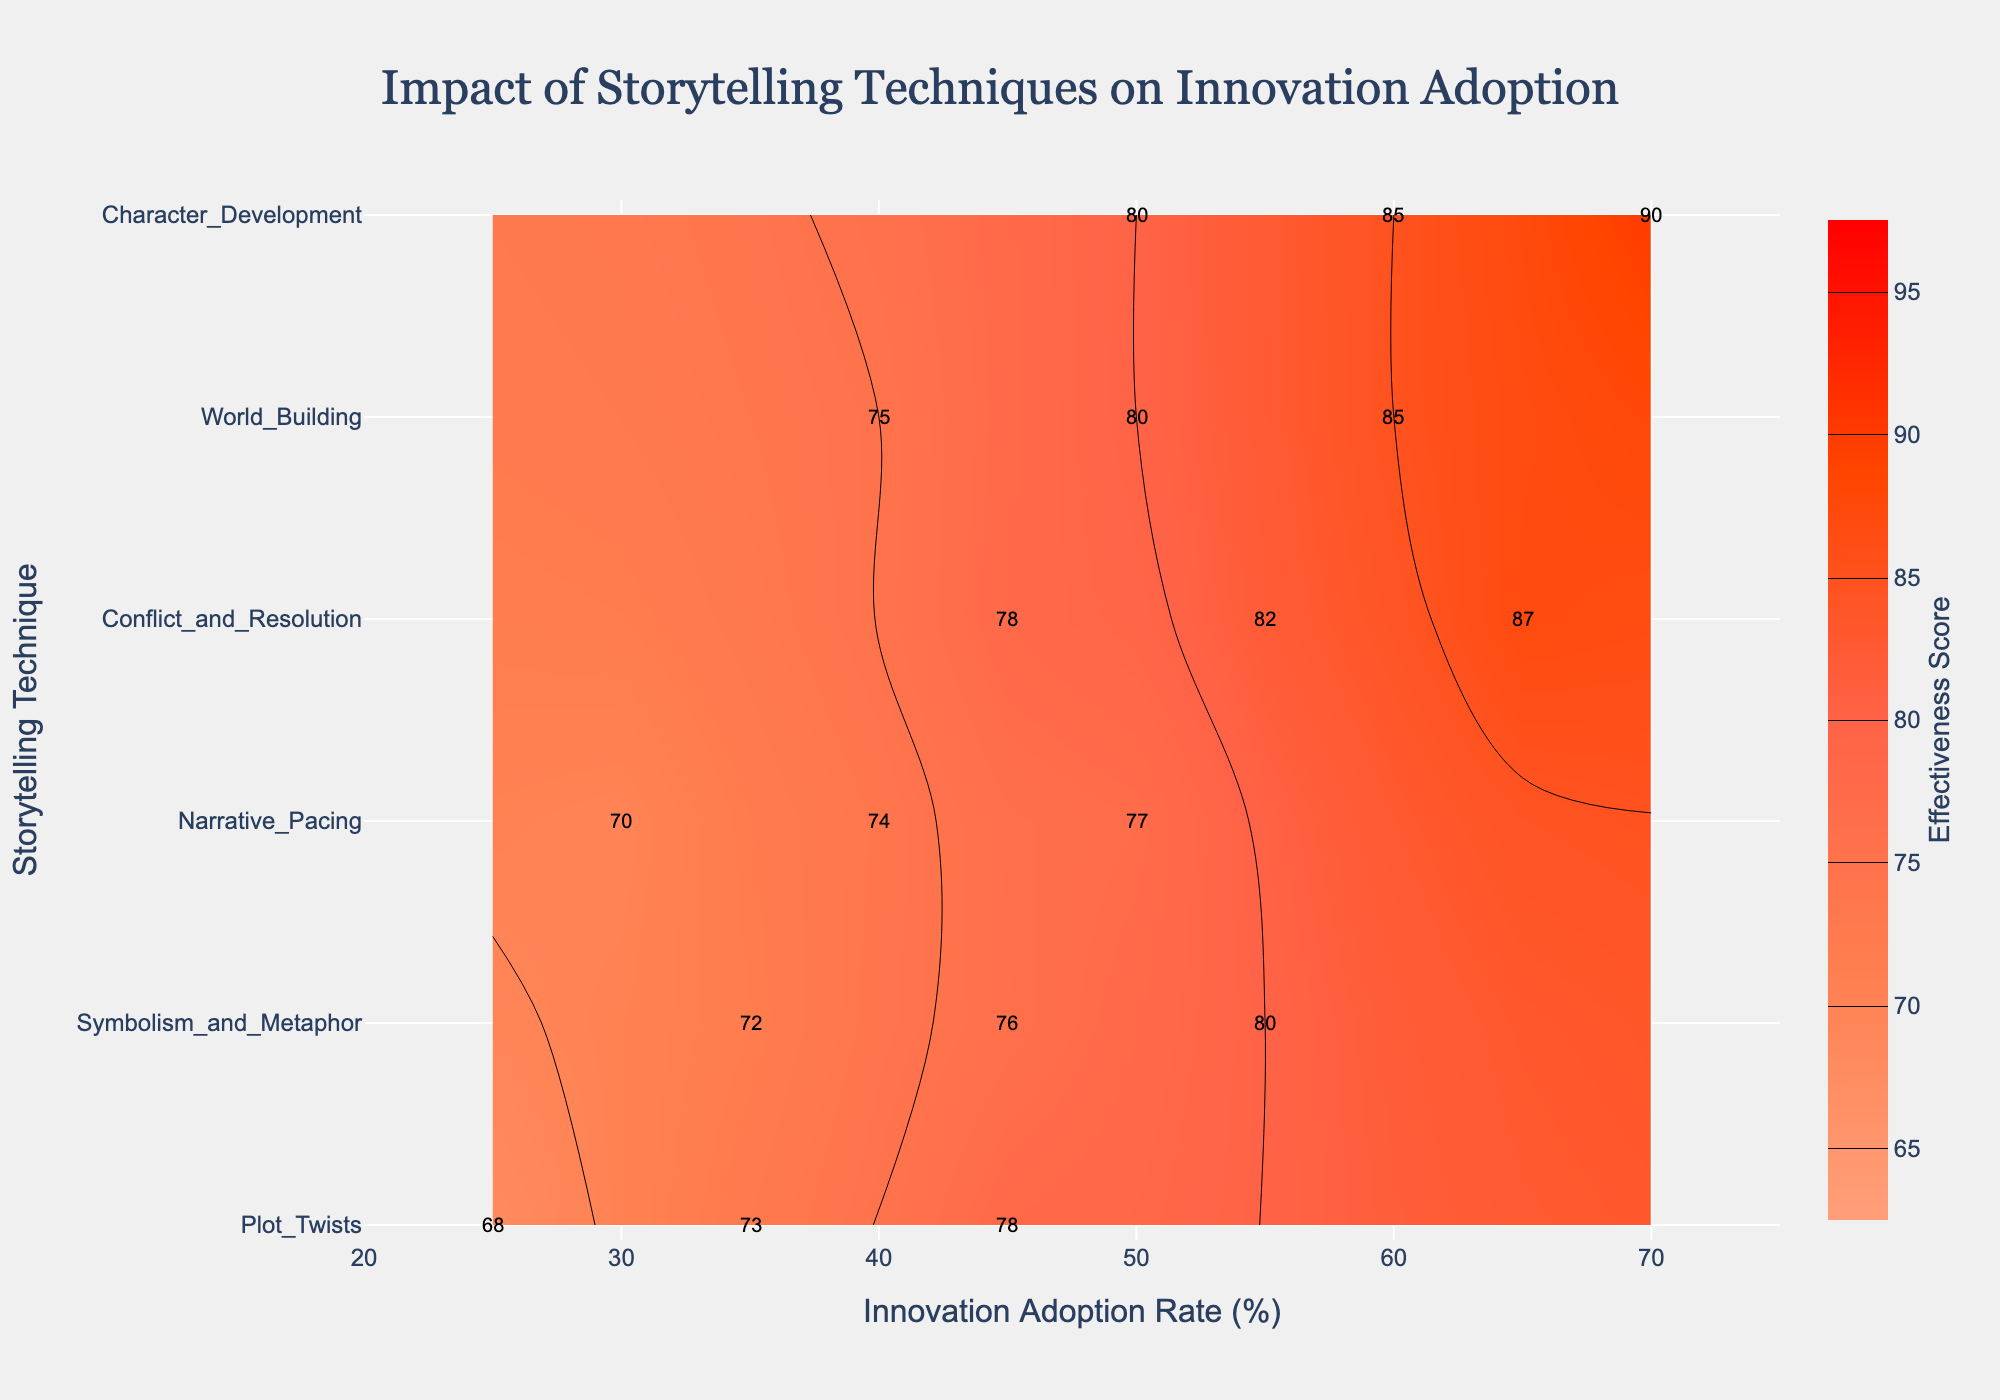What is the title of the contour plot? The title is usually displayed at the top of the figure. In this case, the title "Impact of Storytelling Techniques on Innovation Adoption" is shown at the top-center.
Answer: Impact of Storytelling Techniques on Innovation Adoption How many storytelling techniques are represented in the plot? By observing the y-axis, we can count the distinct categories representing different storytelling techniques. These are "Character Development," "World Building," "Conflict and Resolution," "Narrative Pacing," "Symbolism and Metaphor," and "Plot Twists."
Answer: 6 What is the innovation adoption rate range covered in the plot? The x-axis range shows the minimum and maximum values for the Innovation Adoption Rate. The range starts at 20 and ends at 75.
Answer: 20 to 75 Which storytelling technique has the highest effectiveness score? To find the highest effectiveness score, look at the highest contour level and its labels. "Character Development" has the highest contour label, which is 90.
Answer: Character Development Between which two storytelling techniques is the effectiveness score: 80? Identify the contour corresponding to a score of 80. Both "Character Development" and "World Building" have data points with an effectiveness score of 80.
Answer: Character Development and World Building Which storytelling technique's effectiveness scores range from 68 to 78? Check for the technique where the scores span from 68 to 78. "Plot Twists" has scores of 68, 73, and 78, covering that range.
Answer: Plot Twists What is the average effectiveness score for Narrative Pacing? Average is calculated by summing up the effectiveness scores for "Narrative Pacing" (70, 74, 77) and dividing by the number of data points. The average is (70 + 74 + 77) / 3 = 73.67.
Answer: 73.67 Which storytelling technique shows the most significant increase in effectiveness score with an increase in innovation adoption rate? Analyzing the slope of effectiveness scores against innovation adoption rate. "Character Development" increases from 80 to 90 as the innovation adoption rate goes from 50 to 70, indicating a significant increase.
Answer: Character Development Do any storytelling techniques have overlapping effectiveness scores at different innovation adoption rates? Identifying if the same effectiveness scores appear in different techniques. Both "Conflict and Resolution" and "World Building" have an effectiveness score of 85 at different innovation adoption rates (60 for World Building and 55 for Conflict and Resolution).
Answer: Yes What innovation adoption rate corresponds to an effectiveness score of 82 in Conflict and Resolution? Locate the data point for "Conflict and Resolution" where the effectiveness score is 82. This score corresponds to an innovation adoption rate of 55.
Answer: 55 